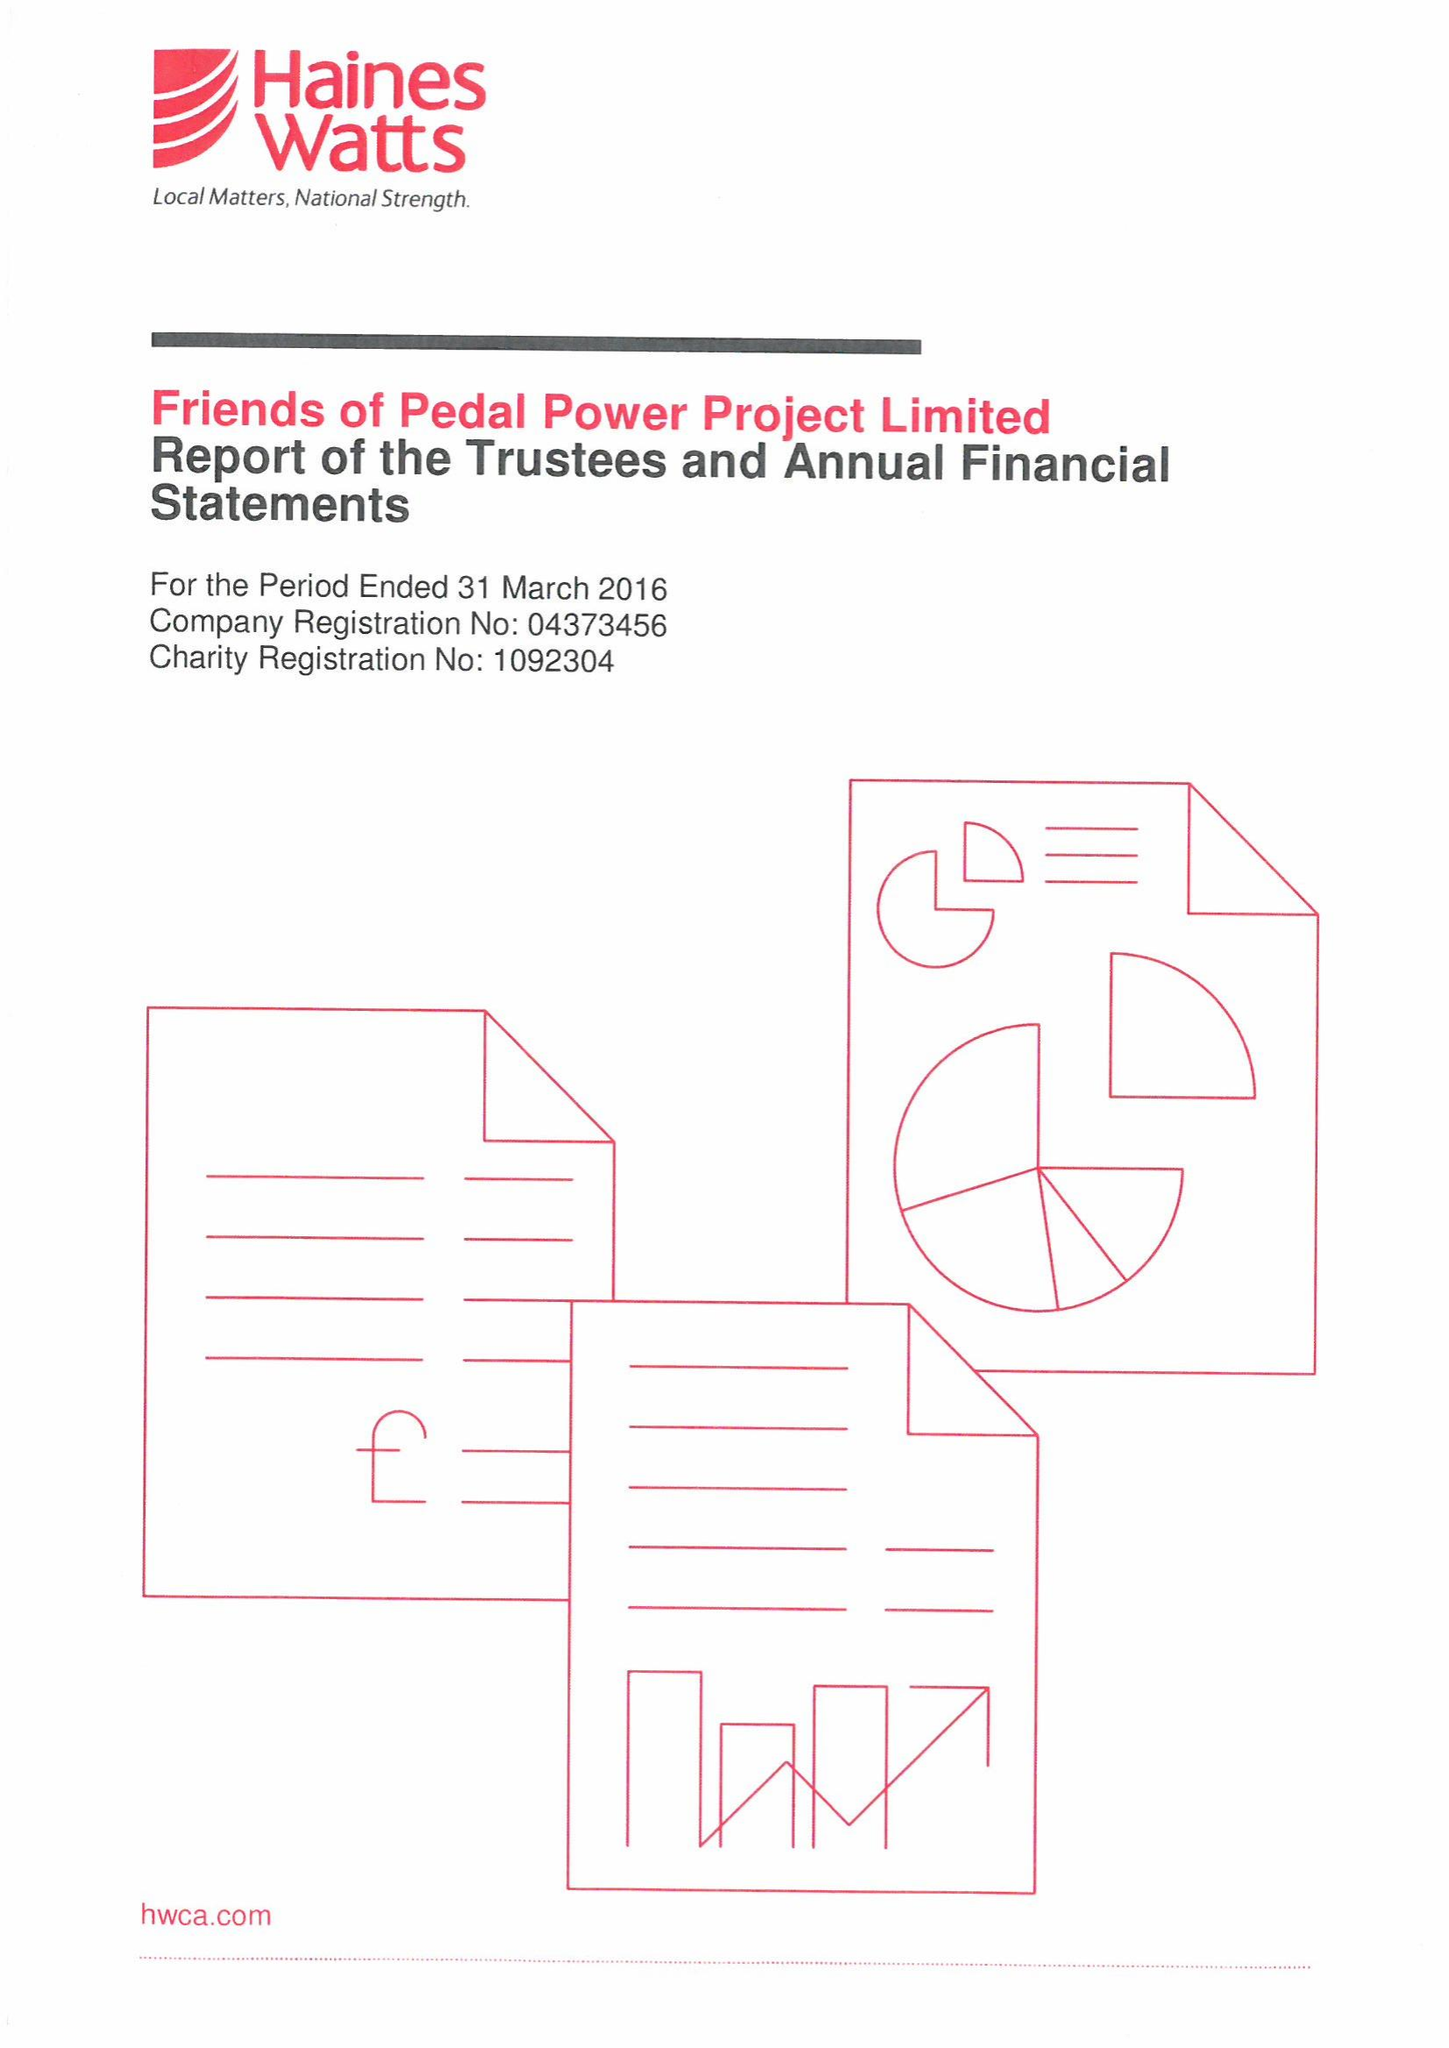What is the value for the charity_name?
Answer the question using a single word or phrase. Friends Of Pedal Power Project Ltd. 